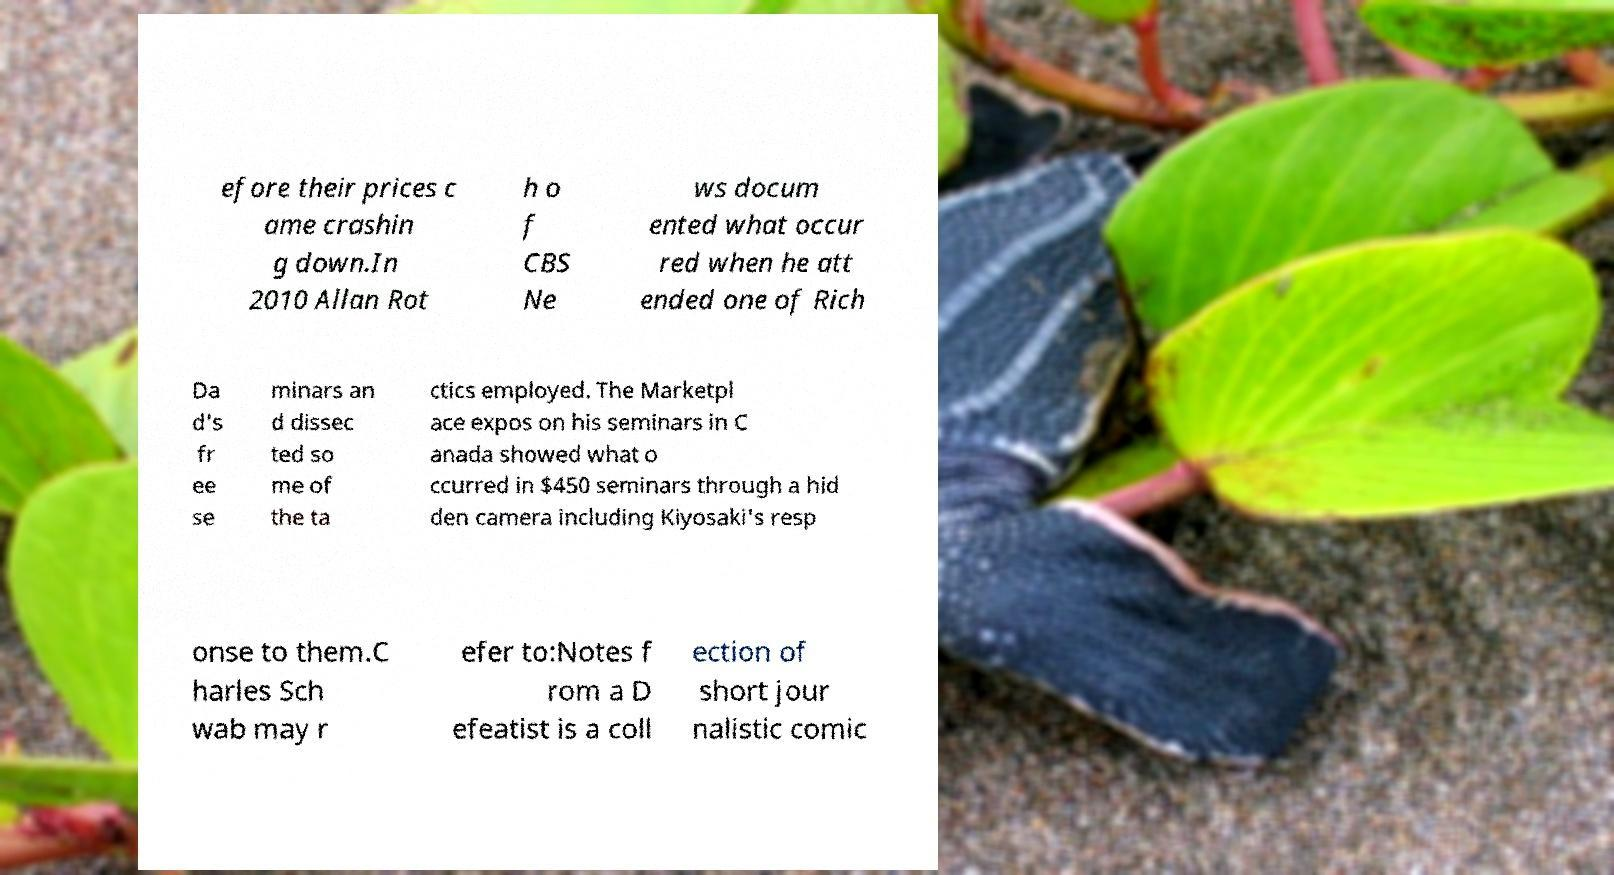Please identify and transcribe the text found in this image. efore their prices c ame crashin g down.In 2010 Allan Rot h o f CBS Ne ws docum ented what occur red when he att ended one of Rich Da d's fr ee se minars an d dissec ted so me of the ta ctics employed. The Marketpl ace expos on his seminars in C anada showed what o ccurred in $450 seminars through a hid den camera including Kiyosaki's resp onse to them.C harles Sch wab may r efer to:Notes f rom a D efeatist is a coll ection of short jour nalistic comic 